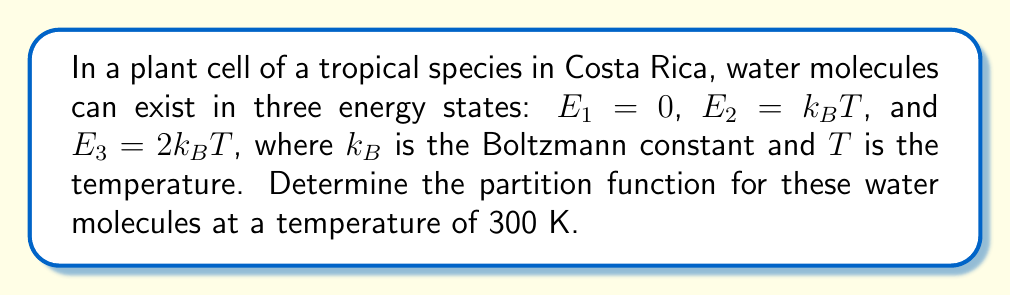Give your solution to this math problem. To solve this problem, we'll follow these steps:

1) Recall the formula for the partition function:
   $$Z = \sum_i g_i e^{-E_i/k_BT}$$
   where $g_i$ is the degeneracy of each state (assumed to be 1 for all states in this case).

2) We have three energy states:
   $E_1 = 0$
   $E_2 = k_BT$
   $E_3 = 2k_BT$

3) Let's calculate the contribution of each state to the partition function:

   For $E_1$: $e^{-E_1/k_BT} = e^0 = 1$

   For $E_2$: $e^{-E_2/k_BT} = e^{-k_BT/k_BT} = e^{-1}$

   For $E_3$: $e^{-E_3/k_BT} = e^{-2k_BT/k_BT} = e^{-2}$

4) Now, we sum these contributions:
   $$Z = 1 + e^{-1} + e^{-2}$$

5) We can calculate this numerically:
   $e^{-1} \approx 0.368$
   $e^{-2} \approx 0.135$

6) Adding these values:
   $$Z \approx 1 + 0.368 + 0.135 = 1.503$$

The temperature (300 K) doesn't directly affect the calculation because the energy levels are given in terms of $k_BT$.
Answer: $Z \approx 1.503$ 